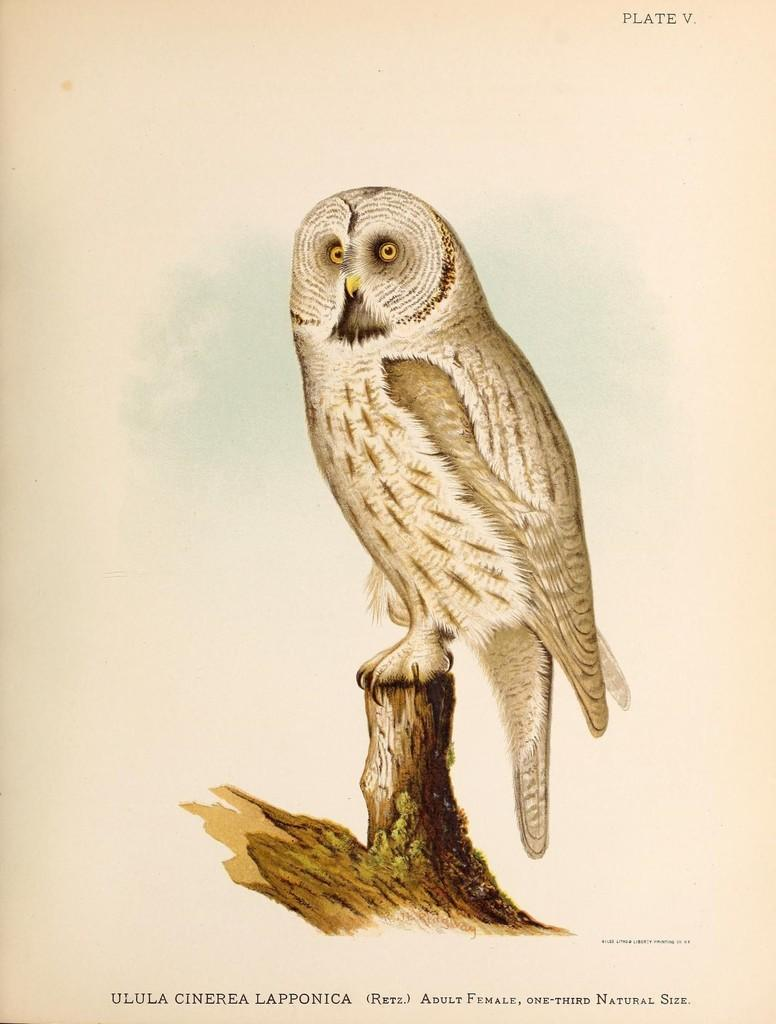What type of animal is in the image? There is an owl in the image. What is the owl sitting on? The owl is on a wooden surface. What type of milk does the owl's dad prefer? There is no information about the owl's dad or their milk preferences in the image. 